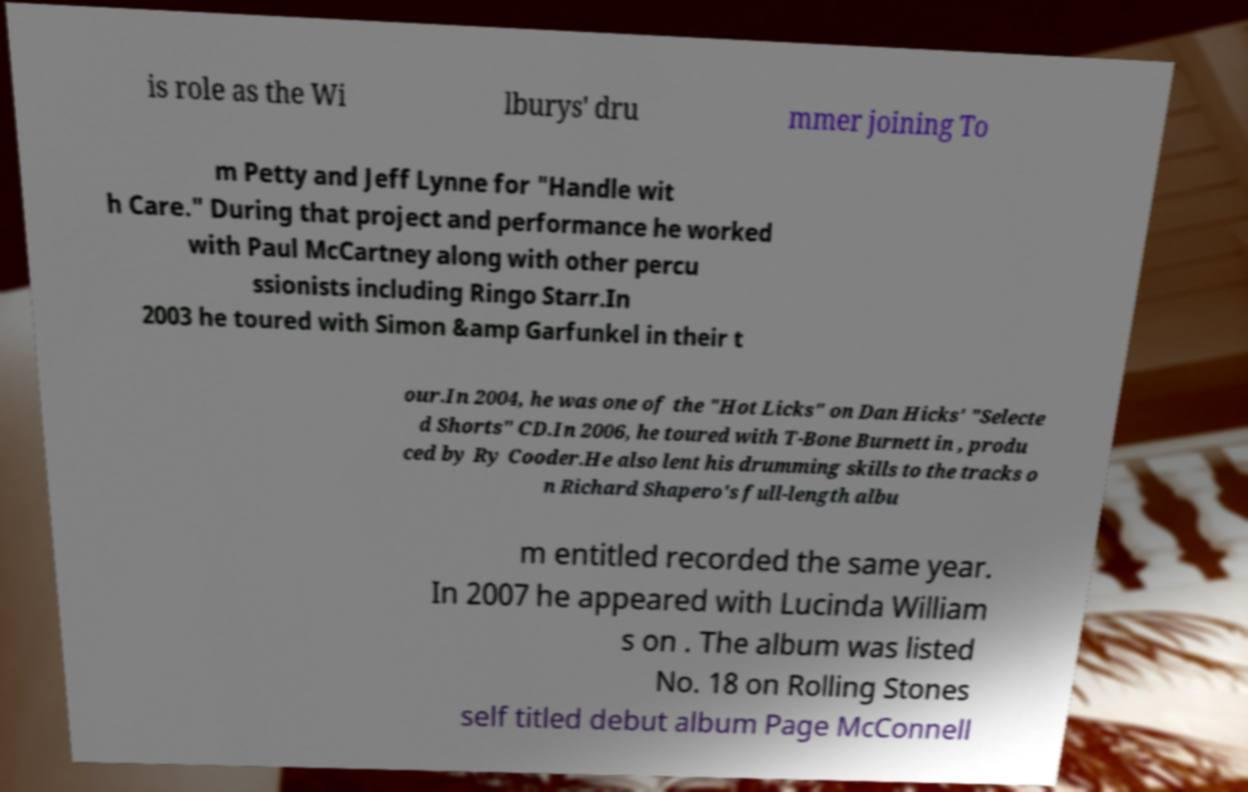Could you extract and type out the text from this image? is role as the Wi lburys' dru mmer joining To m Petty and Jeff Lynne for "Handle wit h Care." During that project and performance he worked with Paul McCartney along with other percu ssionists including Ringo Starr.In 2003 he toured with Simon &amp Garfunkel in their t our.In 2004, he was one of the "Hot Licks" on Dan Hicks' "Selecte d Shorts" CD.In 2006, he toured with T-Bone Burnett in , produ ced by Ry Cooder.He also lent his drumming skills to the tracks o n Richard Shapero's full-length albu m entitled recorded the same year. In 2007 he appeared with Lucinda William s on . The album was listed No. 18 on Rolling Stones self titled debut album Page McConnell 